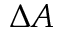Convert formula to latex. <formula><loc_0><loc_0><loc_500><loc_500>\Delta A</formula> 